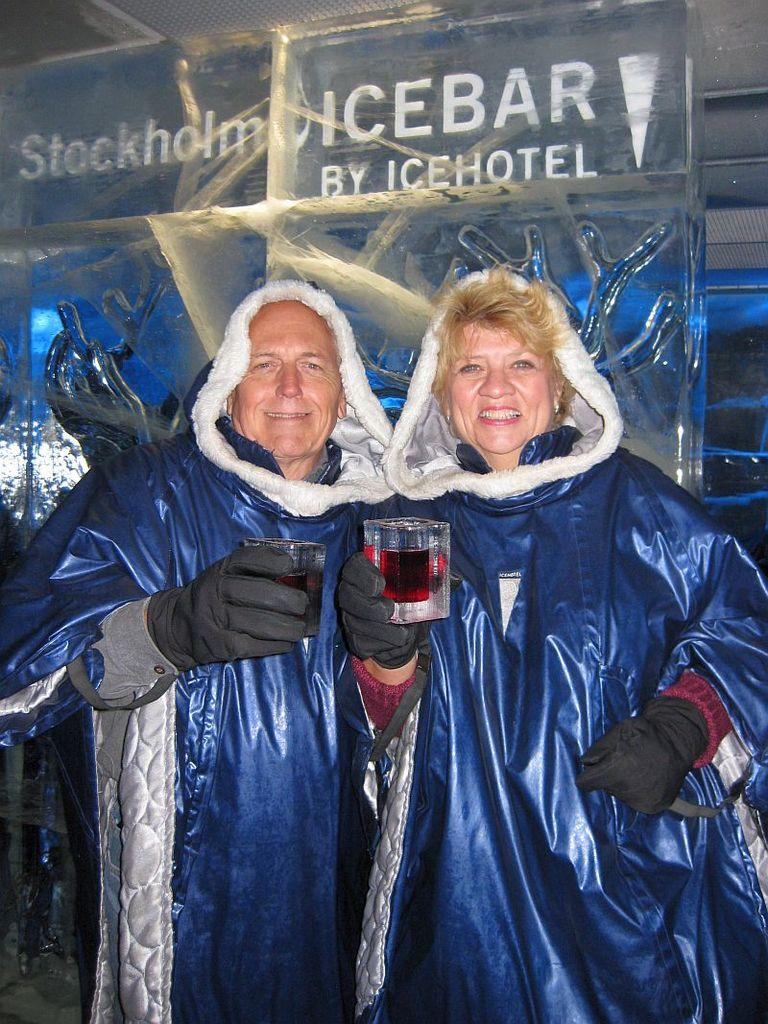<image>
Write a terse but informative summary of the picture. Two adults are standing in front of a Ice Bar advertisement. 